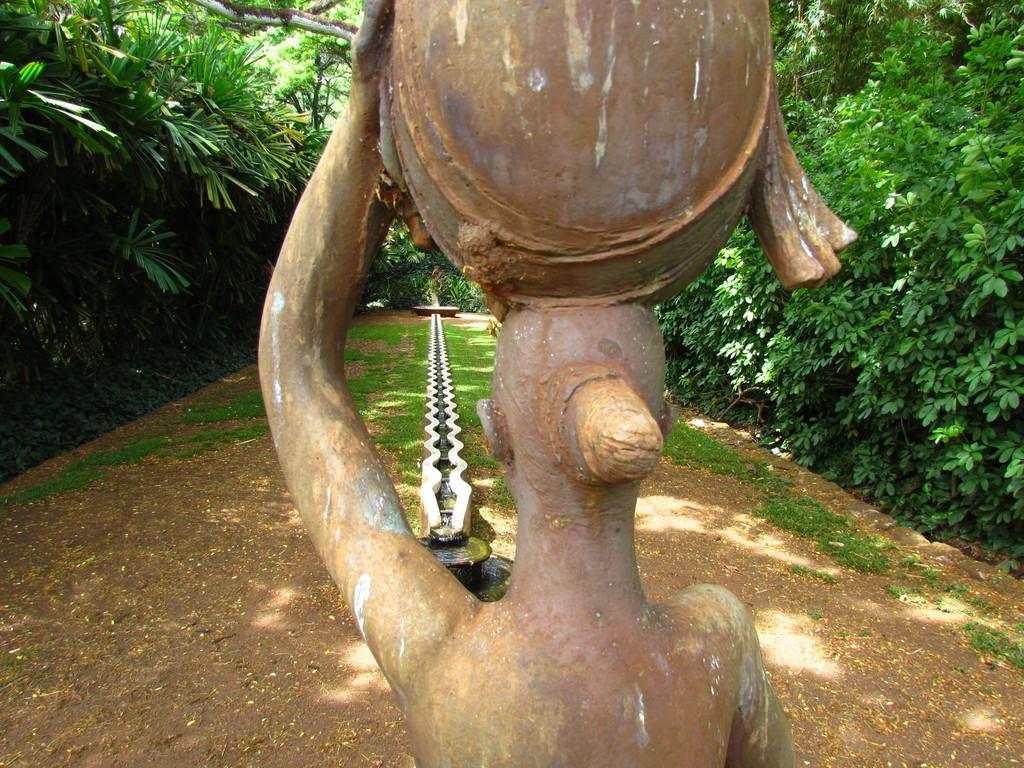What is the main subject in the image? There is a statue in the image. What can be seen in the background of the image? There is grass in the background of the image. What is in the center of the image? There is a channel in the center of the image. What type of vegetation is on the sides of the image? There are trees on the sides of the image. What type of dress is the maid wearing in the image? There is no maid or dress present in the image. What type of road can be seen in the image? There is no road visible in the image; it features a statue, grass, a channel, and trees. 